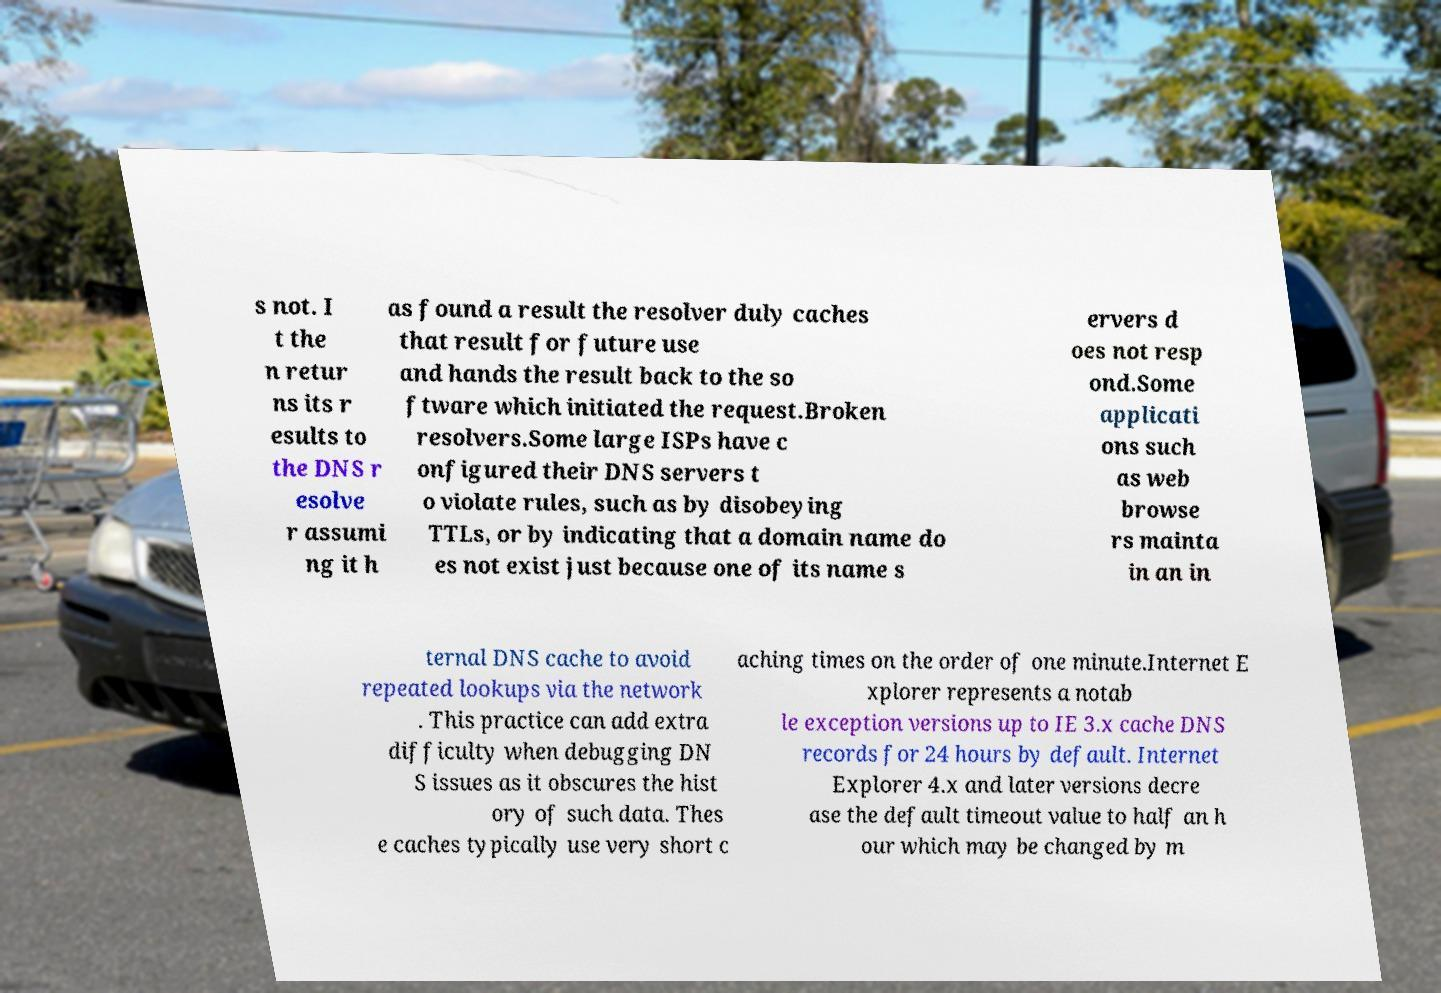Can you accurately transcribe the text from the provided image for me? s not. I t the n retur ns its r esults to the DNS r esolve r assumi ng it h as found a result the resolver duly caches that result for future use and hands the result back to the so ftware which initiated the request.Broken resolvers.Some large ISPs have c onfigured their DNS servers t o violate rules, such as by disobeying TTLs, or by indicating that a domain name do es not exist just because one of its name s ervers d oes not resp ond.Some applicati ons such as web browse rs mainta in an in ternal DNS cache to avoid repeated lookups via the network . This practice can add extra difficulty when debugging DN S issues as it obscures the hist ory of such data. Thes e caches typically use very short c aching times on the order of one minute.Internet E xplorer represents a notab le exception versions up to IE 3.x cache DNS records for 24 hours by default. Internet Explorer 4.x and later versions decre ase the default timeout value to half an h our which may be changed by m 